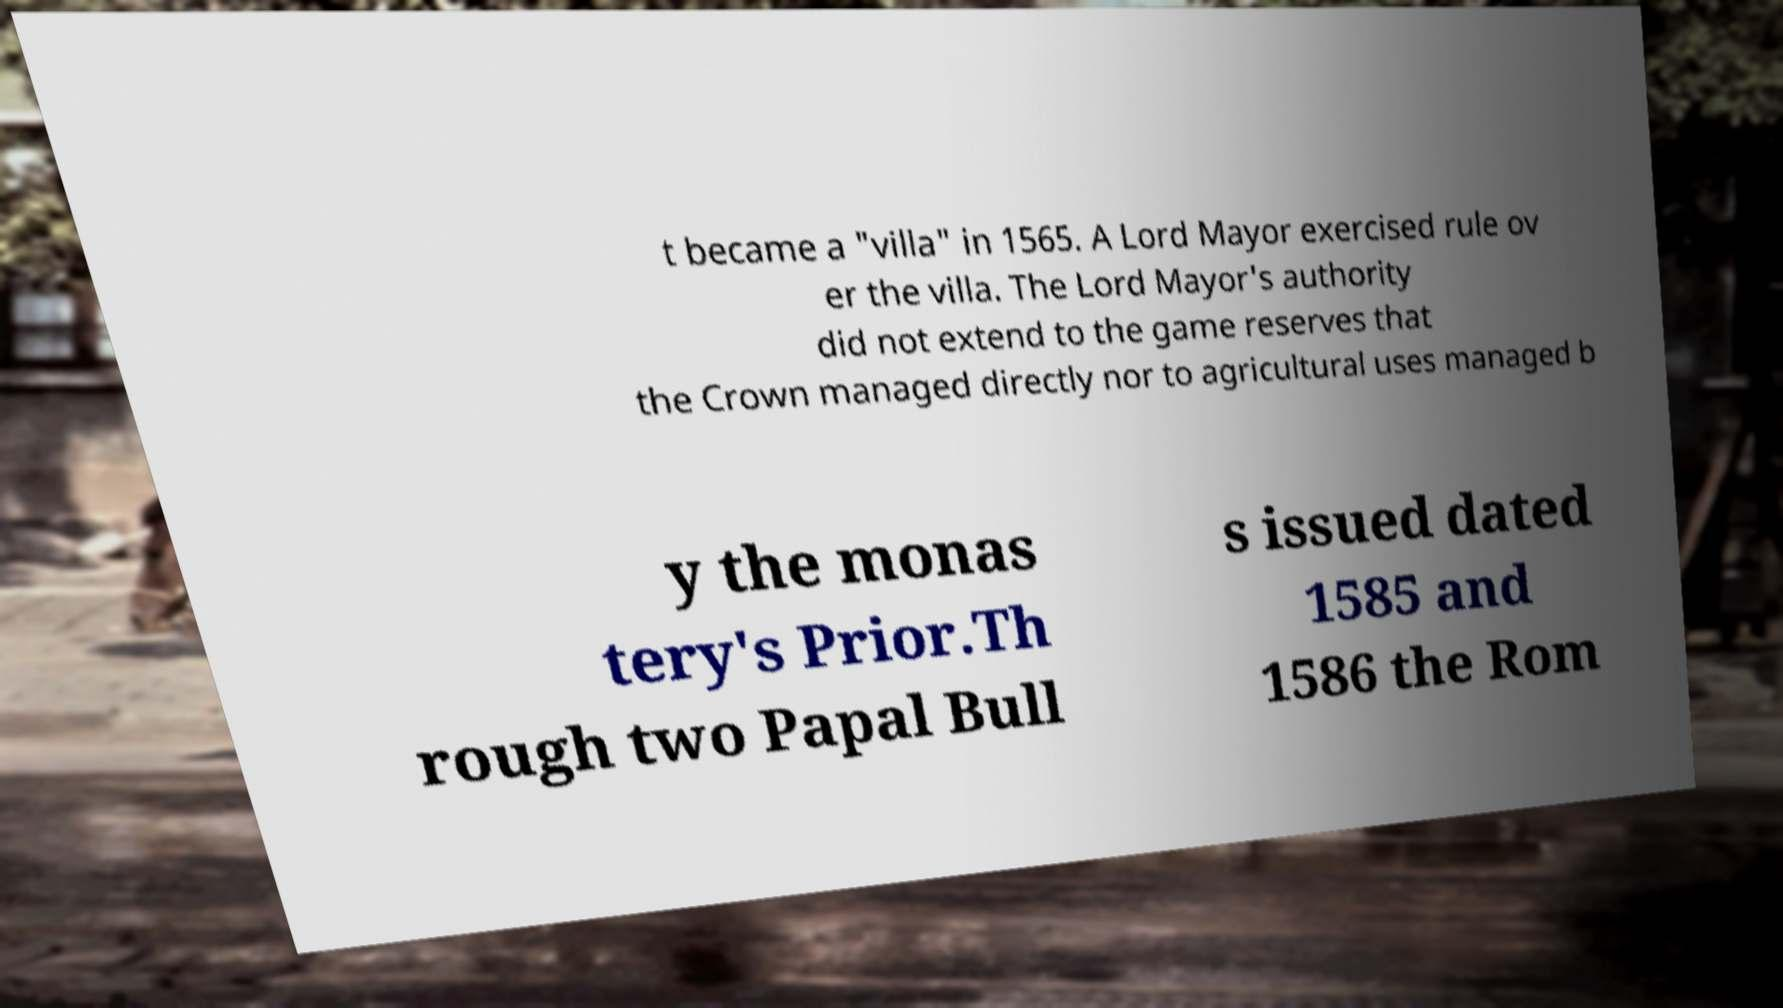Could you assist in decoding the text presented in this image and type it out clearly? t became a "villa" in 1565. A Lord Mayor exercised rule ov er the villa. The Lord Mayor's authority did not extend to the game reserves that the Crown managed directly nor to agricultural uses managed b y the monas tery's Prior.Th rough two Papal Bull s issued dated 1585 and 1586 the Rom 